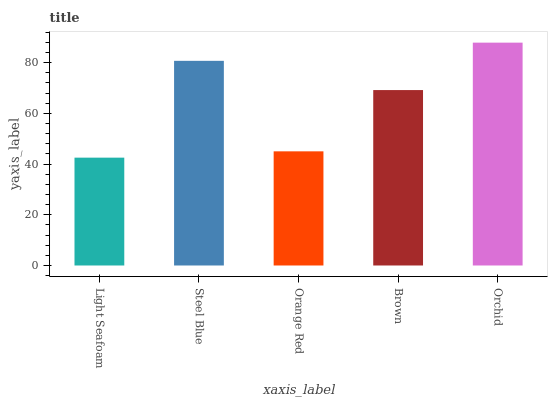Is Light Seafoam the minimum?
Answer yes or no. Yes. Is Orchid the maximum?
Answer yes or no. Yes. Is Steel Blue the minimum?
Answer yes or no. No. Is Steel Blue the maximum?
Answer yes or no. No. Is Steel Blue greater than Light Seafoam?
Answer yes or no. Yes. Is Light Seafoam less than Steel Blue?
Answer yes or no. Yes. Is Light Seafoam greater than Steel Blue?
Answer yes or no. No. Is Steel Blue less than Light Seafoam?
Answer yes or no. No. Is Brown the high median?
Answer yes or no. Yes. Is Brown the low median?
Answer yes or no. Yes. Is Light Seafoam the high median?
Answer yes or no. No. Is Light Seafoam the low median?
Answer yes or no. No. 